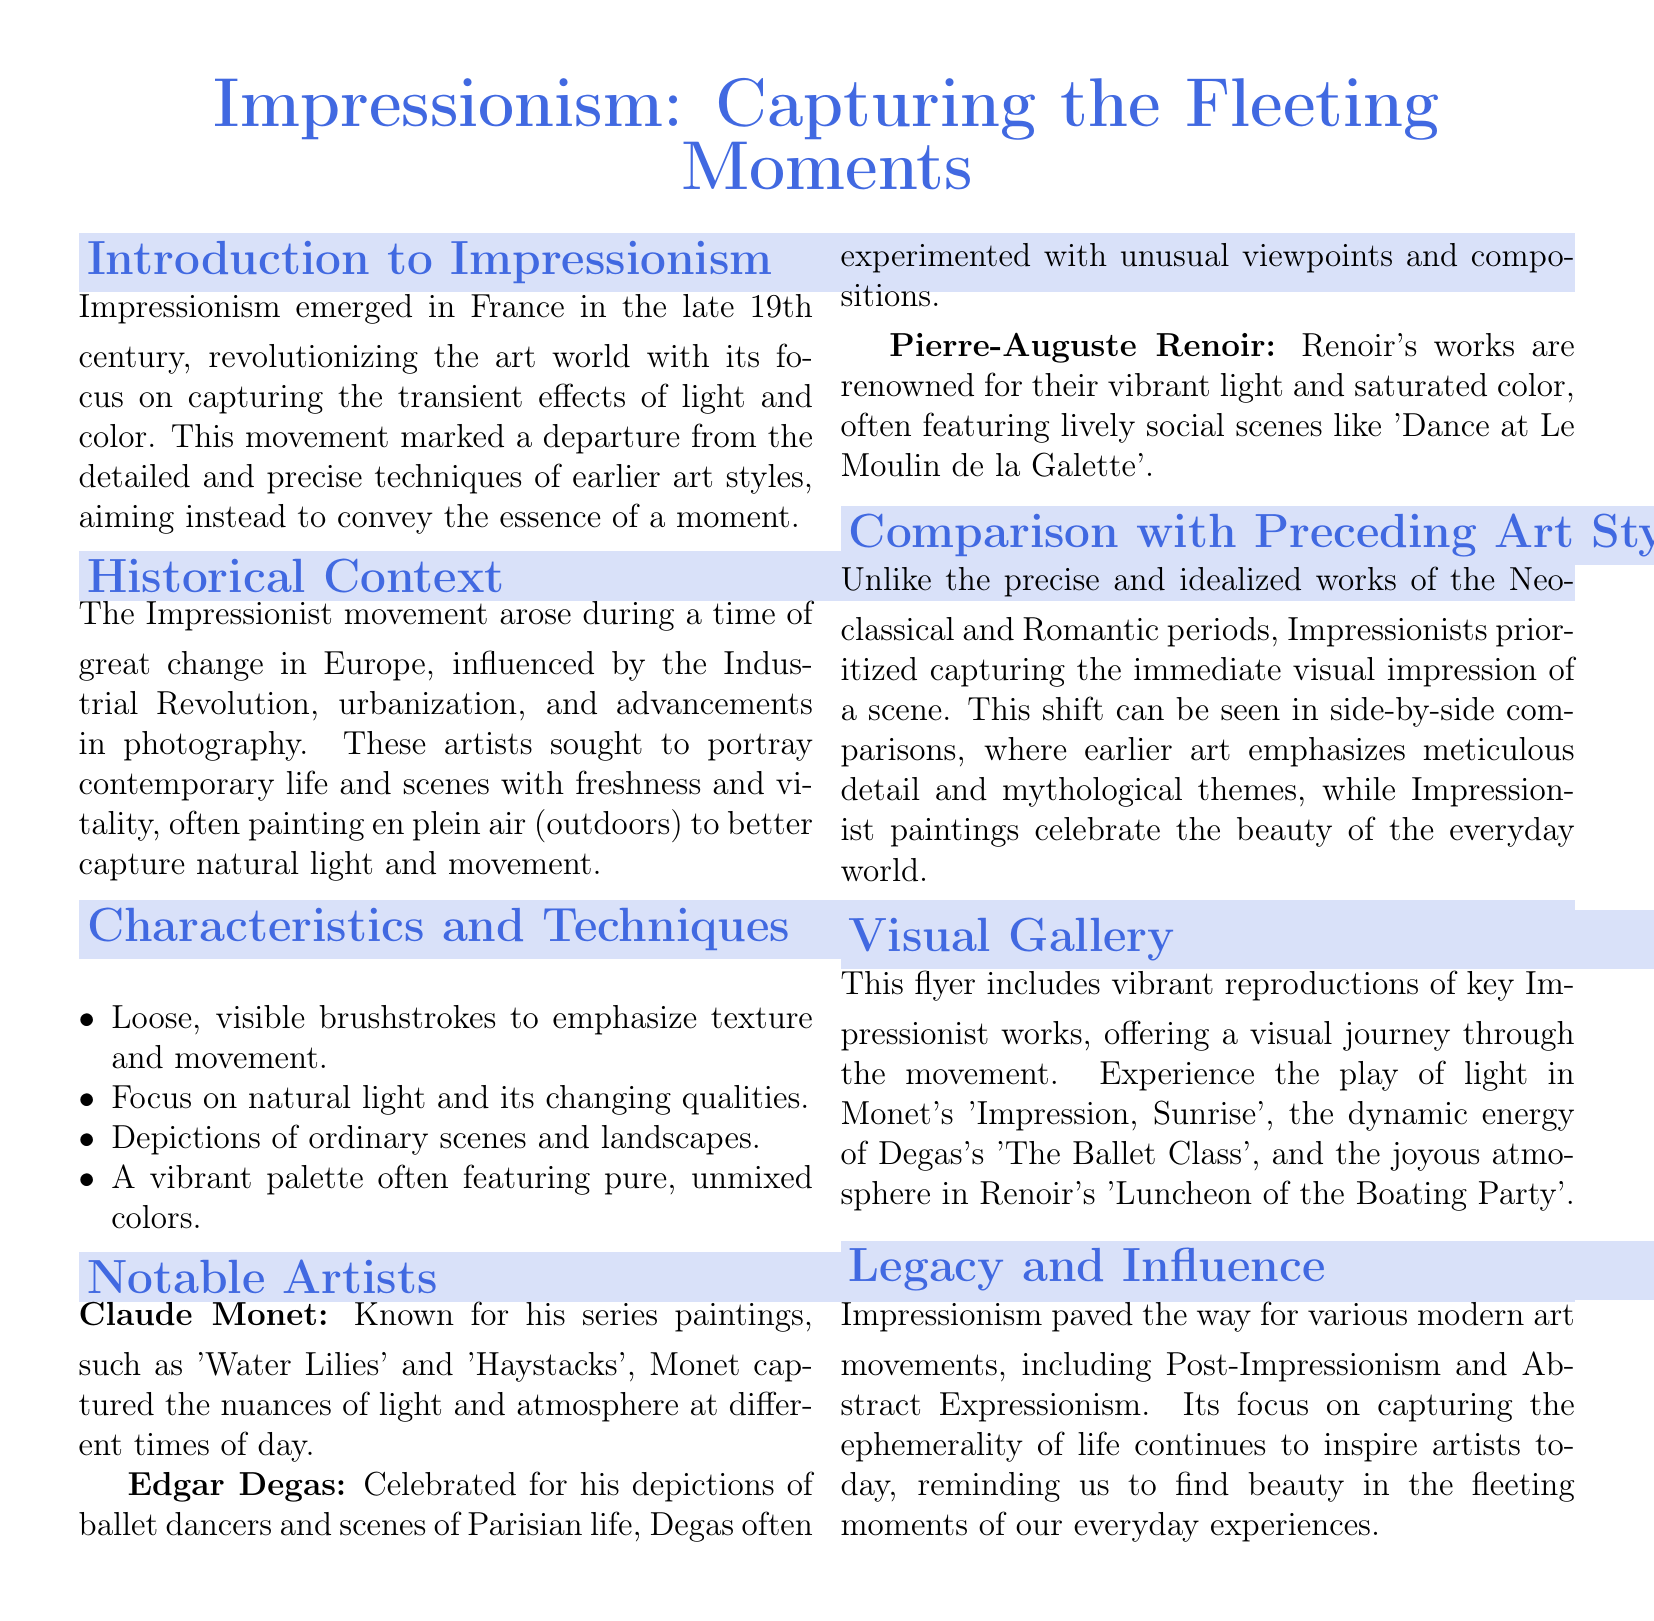What is the title of the flyer? The title summarizes the main theme of the document and is prominently displayed at the top.
Answer: Impressionism: Capturing the Fleeting Moments In which century did Impressionism emerge? The introduction section mentions the period during which the movement began.
Answer: Late 19th century Name one notable artist associated with Impressionism. The document lists several influential artists in the section dedicated to notable figures.
Answer: Claude Monet What technique is emphasized in Impressionist paintings regarding light? The characteristics section specifies a key focus of the Impressionist technique.
Answer: Natural light Which two art movements preceded Impressionism? The comparative analysis mentions the earlier styles that Impressionism diverged from.
Answer: Neoclassical and Romantic What is the primary subject matter of Impressionist paintings? The characteristics section briefly describes the type of scenes Impressionist artists preferred to depict.
Answer: Ordinary scenes and landscapes What kind of colors did Impressionists typically use? The characteristics section outlines a distinct feature of Impressionist color choices.
Answer: Pure, unmixed colors How did Impressionism impact modern art movements? The legacy section describes the influence of Impressionism on subsequent artistic styles.
Answer: Paved the way for various modern art movements Which painting by Monet is mentioned in the gallery section? The visual gallery presents specific works from notable Impressionist artists.
Answer: Impression, Sunrise 